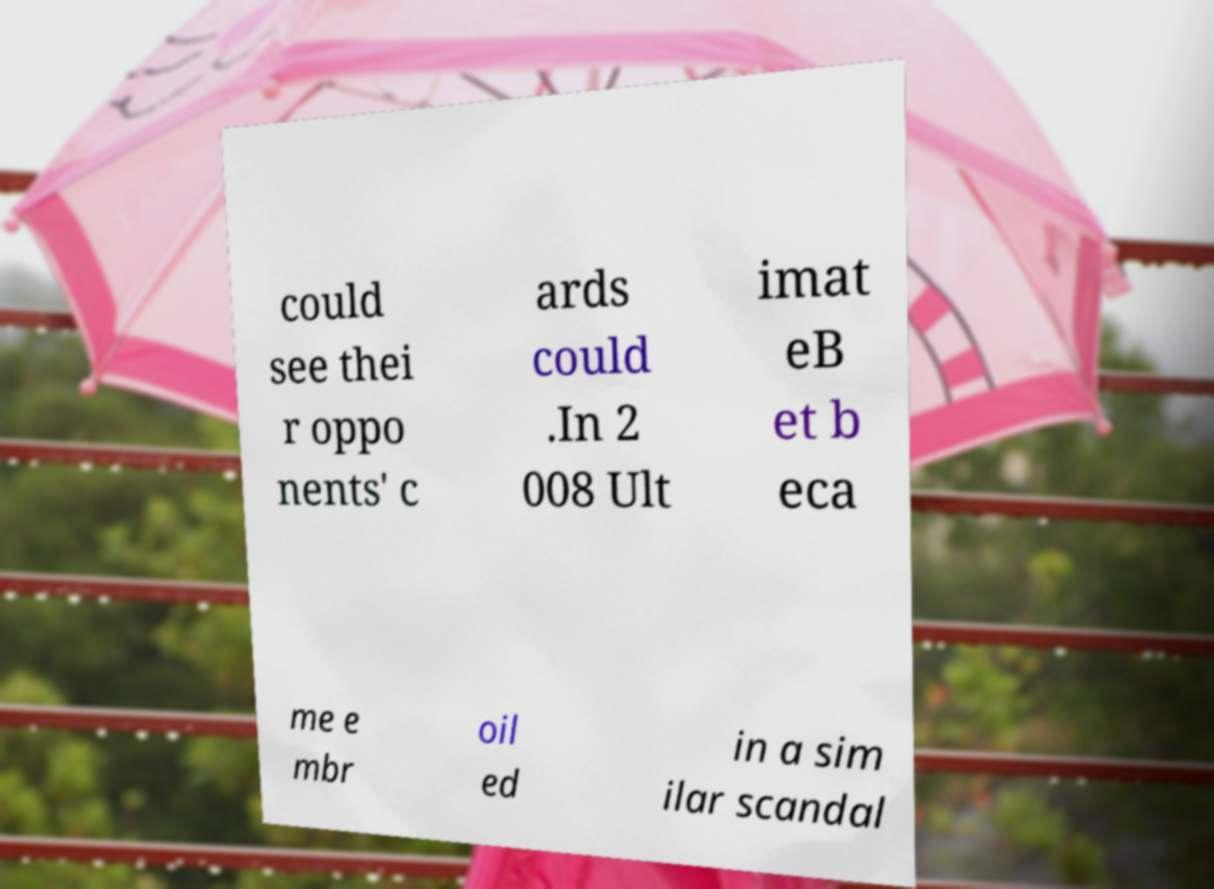I need the written content from this picture converted into text. Can you do that? could see thei r oppo nents' c ards could .In 2 008 Ult imat eB et b eca me e mbr oil ed in a sim ilar scandal 